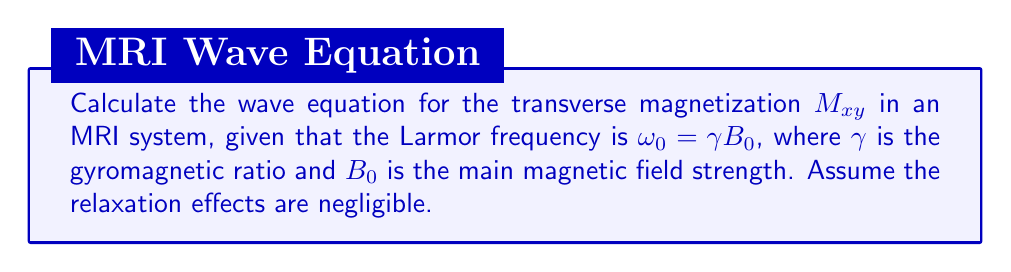What is the answer to this math problem? To derive the wave equation for MRI signal propagation, we'll follow these steps:

1) In MRI, the transverse magnetization $M_{xy}$ precesses around the main magnetic field $B_0$ at the Larmor frequency $\omega_0$.

2) The behavior of $M_{xy}$ can be described by the Bloch equation without relaxation terms:

   $$\frac{d\vec{M}}{dt} = \gamma \vec{M} \times \vec{B}$$

3) In the rotating frame of reference (rotating at $\omega_0$), we can express $M_{xy}$ as a complex number:

   $$M_{xy} = M_x + iM_y$$

4) The time evolution of $M_{xy}$ in this frame is given by:

   $$\frac{dM_{xy}}{dt} = -i\omega_0 M_{xy}$$

5) To obtain the wave equation, we need to take the second time derivative:

   $$\frac{d^2M_{xy}}{dt^2} = -i\omega_0 \frac{dM_{xy}}{dt} = (-i\omega_0)^2 M_{xy} = -\omega_0^2 M_{xy}$$

6) Rearranging this equation, we get:

   $$\frac{d^2M_{xy}}{dt^2} + \omega_0^2 M_{xy} = 0$$

7) This is the standard form of the wave equation for simple harmonic motion, where $\omega_0$ is the angular frequency of oscillation.

8) Substituting $\omega_0 = \gamma B_0$, we obtain the final form of the wave equation:

   $$\frac{d^2M_{xy}}{dt^2} + (\gamma B_0)^2 M_{xy} = 0$$

This equation describes the oscillatory behavior of the MRI signal in the absence of relaxation effects.
Answer: $$\frac{d^2M_{xy}}{dt^2} + (\gamma B_0)^2 M_{xy} = 0$$ 